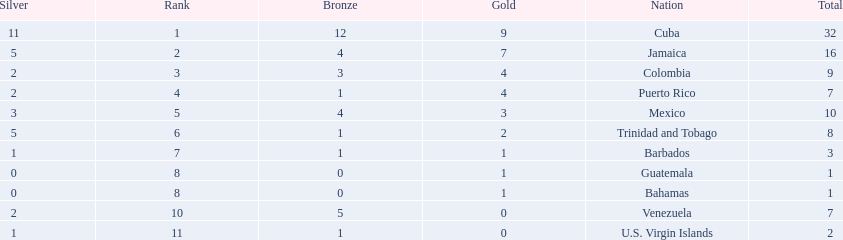Which nations played in the games? Cuba, Jamaica, Colombia, Puerto Rico, Mexico, Trinidad and Tobago, Barbados, Guatemala, Bahamas, Venezuela, U.S. Virgin Islands. How many silver medals did they win? 11, 5, 2, 2, 3, 5, 1, 0, 0, 2, 1. Which team won the most silver? Cuba. 